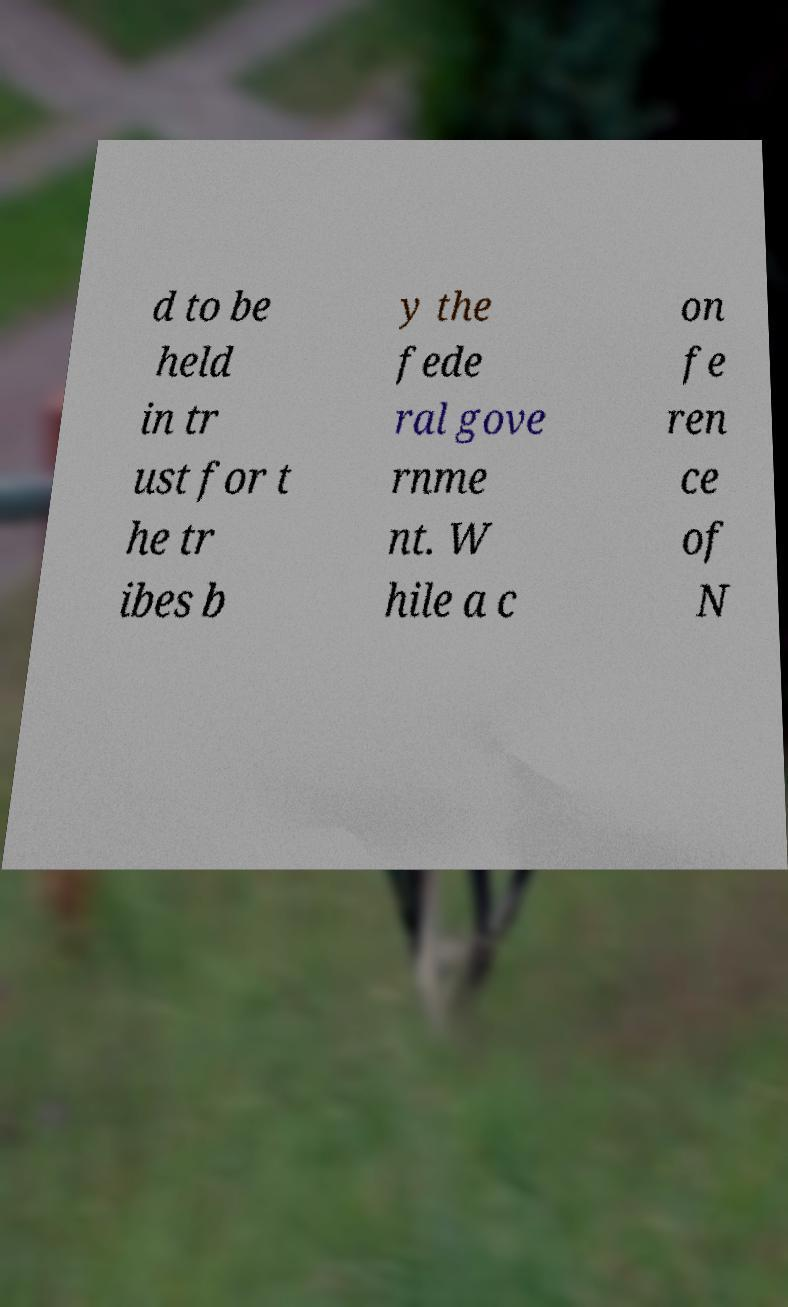What messages or text are displayed in this image? I need them in a readable, typed format. d to be held in tr ust for t he tr ibes b y the fede ral gove rnme nt. W hile a c on fe ren ce of N 